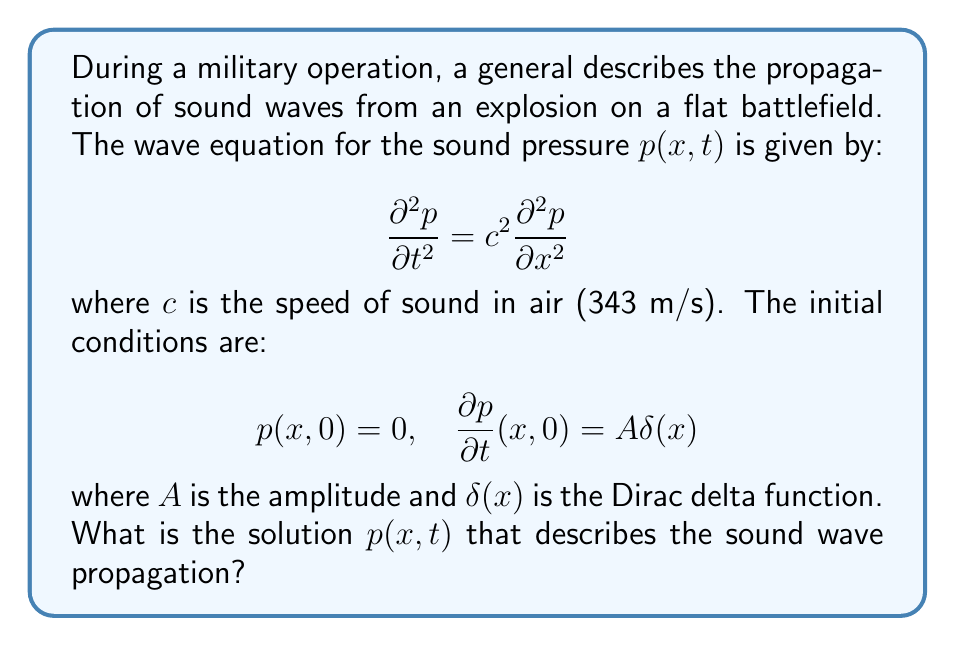Show me your answer to this math problem. To solve this wave equation problem, we'll follow these steps:

1) The general solution to the 1D wave equation is given by D'Alembert's formula:

   $$p(x,t) = \frac{1}{2}[f(x-ct) + f(x+ct)] + \frac{1}{2c}\int_{x-ct}^{x+ct} g(s) ds$$

   where $f$ and $g$ are determined by the initial conditions.

2) From the first initial condition, $p(x,0) = 0$, we can deduce:

   $$f(x) + f(-x) = 0$$

3) From the second initial condition, $\frac{\partial p}{\partial t}(x,0) = A\delta(x)$, we get:

   $$g(x) = A\delta(x)$$

4) Substituting these into D'Alembert's formula:

   $$p(x,t) = \frac{1}{2}[f(x-ct) - f(-(x-ct))] + \frac{A}{2c}\int_{x-ct}^{x+ct} \delta(s) ds$$

5) The integral of the delta function is the Heaviside step function $H(s)$:

   $$p(x,t) = \frac{1}{2}[f(x-ct) - f(-(x-ct))] + \frac{A}{2c}[H(x+ct) - H(x-ct)]$$

6) The step function terms are non-zero only when $-ct < x < ct$. In this region:

   $$p(x,t) = \frac{1}{2}[f(x-ct) - f(-(x-ct))] + \frac{A}{2c}$$

7) To satisfy the initial conditions, we must have:

   $$f(x) = -f(-x) = \frac{A}{2c}\text{sgn}(x)$$

   where $\text{sgn}(x)$ is the sign function.

8) Therefore, the final solution is:

   $$p(x,t) = \frac{A}{2c}[\text{sgn}(x-ct) + 1] = \frac{A}{c}H(ct-|x|)$$
Answer: $p(x,t) = \frac{A}{c}H(ct-|x|)$ 